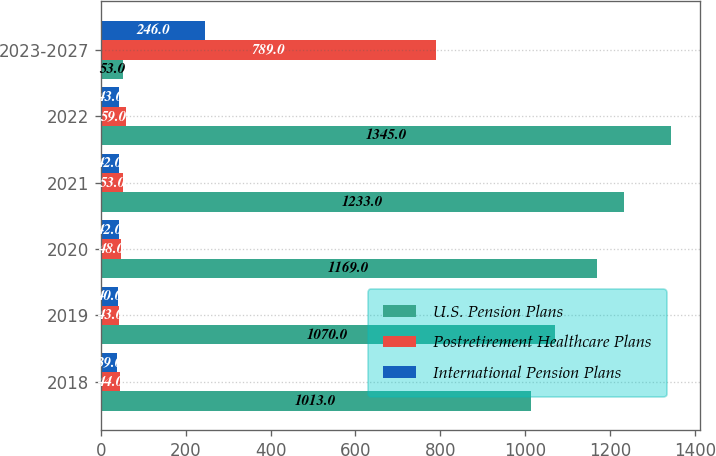Convert chart to OTSL. <chart><loc_0><loc_0><loc_500><loc_500><stacked_bar_chart><ecel><fcel>2018<fcel>2019<fcel>2020<fcel>2021<fcel>2022<fcel>2023-2027<nl><fcel>U.S. Pension Plans<fcel>1013<fcel>1070<fcel>1169<fcel>1233<fcel>1345<fcel>53<nl><fcel>Postretirement Healthcare Plans<fcel>44<fcel>43<fcel>48<fcel>53<fcel>59<fcel>789<nl><fcel>International Pension Plans<fcel>39<fcel>40<fcel>42<fcel>42<fcel>43<fcel>246<nl></chart> 